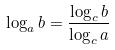<formula> <loc_0><loc_0><loc_500><loc_500>\log _ { a } b = \frac { \log _ { c } b } { \log _ { c } a }</formula> 